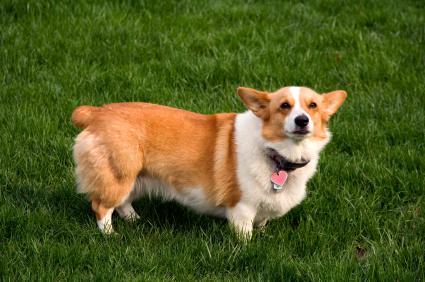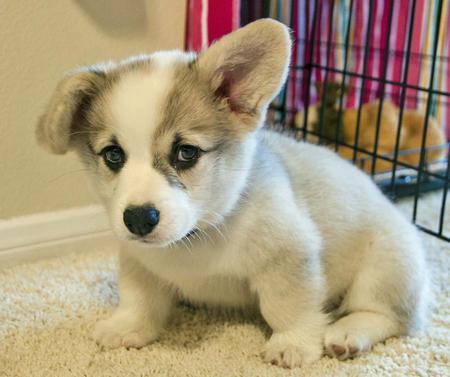The first image is the image on the left, the second image is the image on the right. Given the left and right images, does the statement "The dog standing in the grass is in full profile looking toward the camera." hold true? Answer yes or no. Yes. 